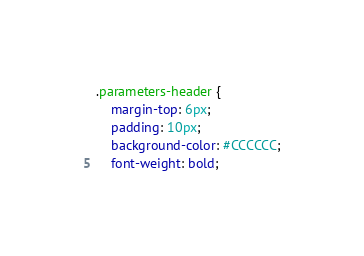Convert code to text. <code><loc_0><loc_0><loc_500><loc_500><_CSS_>.parameters-header {
	margin-top: 6px;
	padding: 10px;
	background-color: #CCCCCC;
	font-weight: bold;</code> 